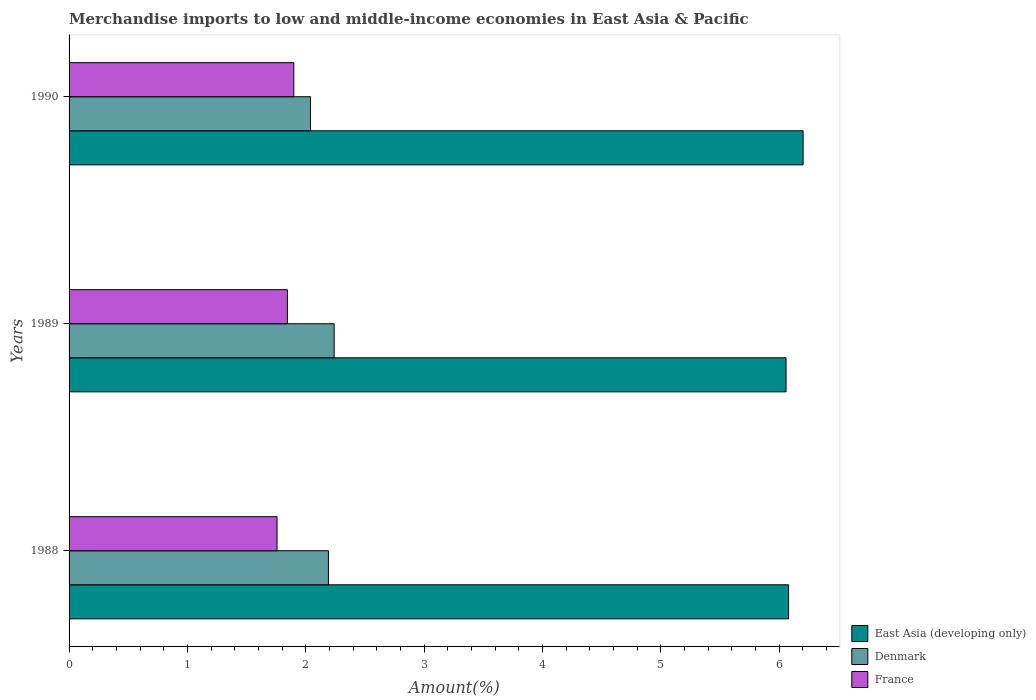How many different coloured bars are there?
Ensure brevity in your answer.  3. How many groups of bars are there?
Provide a succinct answer. 3. Are the number of bars per tick equal to the number of legend labels?
Keep it short and to the point. Yes. How many bars are there on the 3rd tick from the bottom?
Your answer should be compact. 3. What is the label of the 2nd group of bars from the top?
Offer a terse response. 1989. What is the percentage of amount earned from merchandise imports in France in 1988?
Provide a succinct answer. 1.76. Across all years, what is the maximum percentage of amount earned from merchandise imports in East Asia (developing only)?
Your answer should be very brief. 6.2. Across all years, what is the minimum percentage of amount earned from merchandise imports in East Asia (developing only)?
Provide a short and direct response. 6.06. In which year was the percentage of amount earned from merchandise imports in East Asia (developing only) maximum?
Keep it short and to the point. 1990. In which year was the percentage of amount earned from merchandise imports in Denmark minimum?
Provide a succinct answer. 1990. What is the total percentage of amount earned from merchandise imports in East Asia (developing only) in the graph?
Provide a succinct answer. 18.34. What is the difference between the percentage of amount earned from merchandise imports in France in 1989 and that in 1990?
Make the answer very short. -0.05. What is the difference between the percentage of amount earned from merchandise imports in France in 1990 and the percentage of amount earned from merchandise imports in East Asia (developing only) in 1988?
Your response must be concise. -4.18. What is the average percentage of amount earned from merchandise imports in East Asia (developing only) per year?
Provide a short and direct response. 6.11. In the year 1989, what is the difference between the percentage of amount earned from merchandise imports in Denmark and percentage of amount earned from merchandise imports in East Asia (developing only)?
Provide a short and direct response. -3.82. What is the ratio of the percentage of amount earned from merchandise imports in East Asia (developing only) in 1989 to that in 1990?
Provide a short and direct response. 0.98. What is the difference between the highest and the second highest percentage of amount earned from merchandise imports in East Asia (developing only)?
Your response must be concise. 0.12. What is the difference between the highest and the lowest percentage of amount earned from merchandise imports in France?
Make the answer very short. 0.14. What does the 1st bar from the top in 1990 represents?
Ensure brevity in your answer.  France. Is it the case that in every year, the sum of the percentage of amount earned from merchandise imports in France and percentage of amount earned from merchandise imports in Denmark is greater than the percentage of amount earned from merchandise imports in East Asia (developing only)?
Offer a terse response. No. What is the difference between two consecutive major ticks on the X-axis?
Keep it short and to the point. 1. Does the graph contain any zero values?
Your answer should be very brief. No. Does the graph contain grids?
Your response must be concise. No. Where does the legend appear in the graph?
Offer a very short reply. Bottom right. What is the title of the graph?
Offer a terse response. Merchandise imports to low and middle-income economies in East Asia & Pacific. Does "Austria" appear as one of the legend labels in the graph?
Provide a succinct answer. No. What is the label or title of the X-axis?
Give a very brief answer. Amount(%). What is the Amount(%) of East Asia (developing only) in 1988?
Your answer should be compact. 6.08. What is the Amount(%) of Denmark in 1988?
Your answer should be compact. 2.19. What is the Amount(%) in France in 1988?
Offer a very short reply. 1.76. What is the Amount(%) in East Asia (developing only) in 1989?
Your response must be concise. 6.06. What is the Amount(%) in Denmark in 1989?
Your answer should be very brief. 2.24. What is the Amount(%) of France in 1989?
Give a very brief answer. 1.84. What is the Amount(%) of East Asia (developing only) in 1990?
Provide a succinct answer. 6.2. What is the Amount(%) in Denmark in 1990?
Your response must be concise. 2.04. What is the Amount(%) of France in 1990?
Your answer should be very brief. 1.9. Across all years, what is the maximum Amount(%) in East Asia (developing only)?
Offer a very short reply. 6.2. Across all years, what is the maximum Amount(%) of Denmark?
Your answer should be compact. 2.24. Across all years, what is the maximum Amount(%) of France?
Keep it short and to the point. 1.9. Across all years, what is the minimum Amount(%) in East Asia (developing only)?
Ensure brevity in your answer.  6.06. Across all years, what is the minimum Amount(%) of Denmark?
Provide a succinct answer. 2.04. Across all years, what is the minimum Amount(%) of France?
Offer a terse response. 1.76. What is the total Amount(%) of East Asia (developing only) in the graph?
Offer a terse response. 18.34. What is the total Amount(%) in Denmark in the graph?
Offer a terse response. 6.47. What is the total Amount(%) of France in the graph?
Provide a succinct answer. 5.5. What is the difference between the Amount(%) in East Asia (developing only) in 1988 and that in 1989?
Your answer should be compact. 0.02. What is the difference between the Amount(%) in Denmark in 1988 and that in 1989?
Your answer should be compact. -0.05. What is the difference between the Amount(%) of France in 1988 and that in 1989?
Your answer should be very brief. -0.09. What is the difference between the Amount(%) of East Asia (developing only) in 1988 and that in 1990?
Make the answer very short. -0.12. What is the difference between the Amount(%) in Denmark in 1988 and that in 1990?
Your answer should be very brief. 0.15. What is the difference between the Amount(%) of France in 1988 and that in 1990?
Your response must be concise. -0.14. What is the difference between the Amount(%) of East Asia (developing only) in 1989 and that in 1990?
Provide a succinct answer. -0.14. What is the difference between the Amount(%) of Denmark in 1989 and that in 1990?
Ensure brevity in your answer.  0.2. What is the difference between the Amount(%) of France in 1989 and that in 1990?
Offer a terse response. -0.05. What is the difference between the Amount(%) in East Asia (developing only) in 1988 and the Amount(%) in Denmark in 1989?
Give a very brief answer. 3.84. What is the difference between the Amount(%) in East Asia (developing only) in 1988 and the Amount(%) in France in 1989?
Make the answer very short. 4.24. What is the difference between the Amount(%) in Denmark in 1988 and the Amount(%) in France in 1989?
Ensure brevity in your answer.  0.35. What is the difference between the Amount(%) in East Asia (developing only) in 1988 and the Amount(%) in Denmark in 1990?
Make the answer very short. 4.04. What is the difference between the Amount(%) of East Asia (developing only) in 1988 and the Amount(%) of France in 1990?
Your answer should be very brief. 4.18. What is the difference between the Amount(%) of Denmark in 1988 and the Amount(%) of France in 1990?
Offer a very short reply. 0.29. What is the difference between the Amount(%) in East Asia (developing only) in 1989 and the Amount(%) in Denmark in 1990?
Give a very brief answer. 4.02. What is the difference between the Amount(%) of East Asia (developing only) in 1989 and the Amount(%) of France in 1990?
Keep it short and to the point. 4.16. What is the difference between the Amount(%) of Denmark in 1989 and the Amount(%) of France in 1990?
Offer a terse response. 0.34. What is the average Amount(%) in East Asia (developing only) per year?
Offer a very short reply. 6.11. What is the average Amount(%) of Denmark per year?
Offer a very short reply. 2.16. What is the average Amount(%) in France per year?
Provide a succinct answer. 1.83. In the year 1988, what is the difference between the Amount(%) in East Asia (developing only) and Amount(%) in Denmark?
Offer a terse response. 3.89. In the year 1988, what is the difference between the Amount(%) of East Asia (developing only) and Amount(%) of France?
Keep it short and to the point. 4.32. In the year 1988, what is the difference between the Amount(%) in Denmark and Amount(%) in France?
Provide a succinct answer. 0.43. In the year 1989, what is the difference between the Amount(%) of East Asia (developing only) and Amount(%) of Denmark?
Offer a very short reply. 3.82. In the year 1989, what is the difference between the Amount(%) of East Asia (developing only) and Amount(%) of France?
Your answer should be very brief. 4.21. In the year 1989, what is the difference between the Amount(%) of Denmark and Amount(%) of France?
Offer a very short reply. 0.4. In the year 1990, what is the difference between the Amount(%) of East Asia (developing only) and Amount(%) of Denmark?
Provide a succinct answer. 4.16. In the year 1990, what is the difference between the Amount(%) of East Asia (developing only) and Amount(%) of France?
Your answer should be very brief. 4.3. In the year 1990, what is the difference between the Amount(%) in Denmark and Amount(%) in France?
Make the answer very short. 0.14. What is the ratio of the Amount(%) in Denmark in 1988 to that in 1989?
Give a very brief answer. 0.98. What is the ratio of the Amount(%) of France in 1988 to that in 1989?
Your answer should be compact. 0.95. What is the ratio of the Amount(%) in East Asia (developing only) in 1988 to that in 1990?
Offer a terse response. 0.98. What is the ratio of the Amount(%) of Denmark in 1988 to that in 1990?
Provide a succinct answer. 1.07. What is the ratio of the Amount(%) in France in 1988 to that in 1990?
Your answer should be compact. 0.93. What is the ratio of the Amount(%) of East Asia (developing only) in 1989 to that in 1990?
Offer a very short reply. 0.98. What is the ratio of the Amount(%) in Denmark in 1989 to that in 1990?
Your response must be concise. 1.1. What is the ratio of the Amount(%) in France in 1989 to that in 1990?
Your answer should be very brief. 0.97. What is the difference between the highest and the second highest Amount(%) of East Asia (developing only)?
Ensure brevity in your answer.  0.12. What is the difference between the highest and the second highest Amount(%) of Denmark?
Your response must be concise. 0.05. What is the difference between the highest and the second highest Amount(%) of France?
Your answer should be compact. 0.05. What is the difference between the highest and the lowest Amount(%) of East Asia (developing only)?
Your answer should be compact. 0.14. What is the difference between the highest and the lowest Amount(%) in Denmark?
Offer a terse response. 0.2. What is the difference between the highest and the lowest Amount(%) in France?
Give a very brief answer. 0.14. 